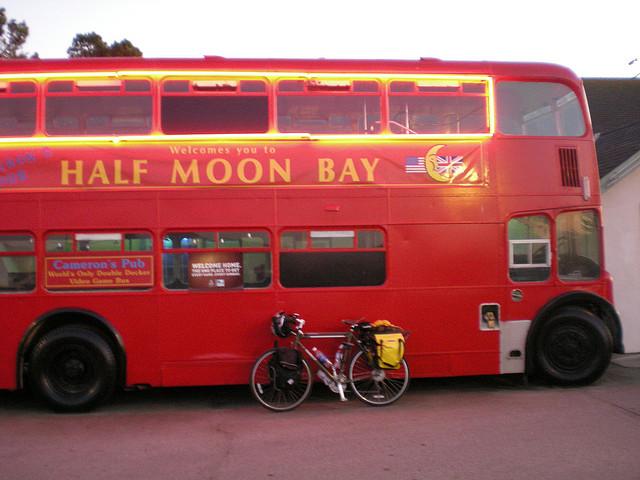What country is most likely to have this type of bus?
Be succinct. England. What does it say on the side of the bus?
Keep it brief. Half moon bay. What is written on the bus?
Write a very short answer. Half moon bay. What is the yellow object on the back of the bicycle?
Concise answer only. Bag. 